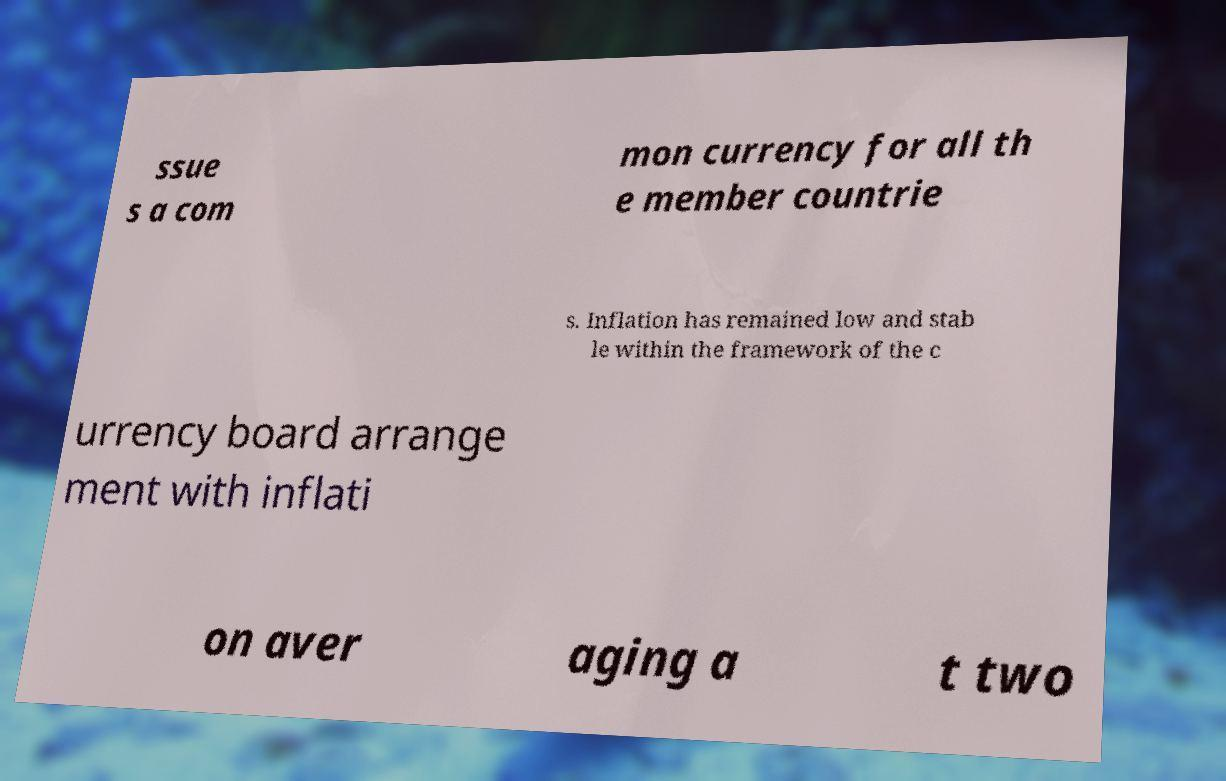There's text embedded in this image that I need extracted. Can you transcribe it verbatim? ssue s a com mon currency for all th e member countrie s. Inflation has remained low and stab le within the framework of the c urrency board arrange ment with inflati on aver aging a t two 